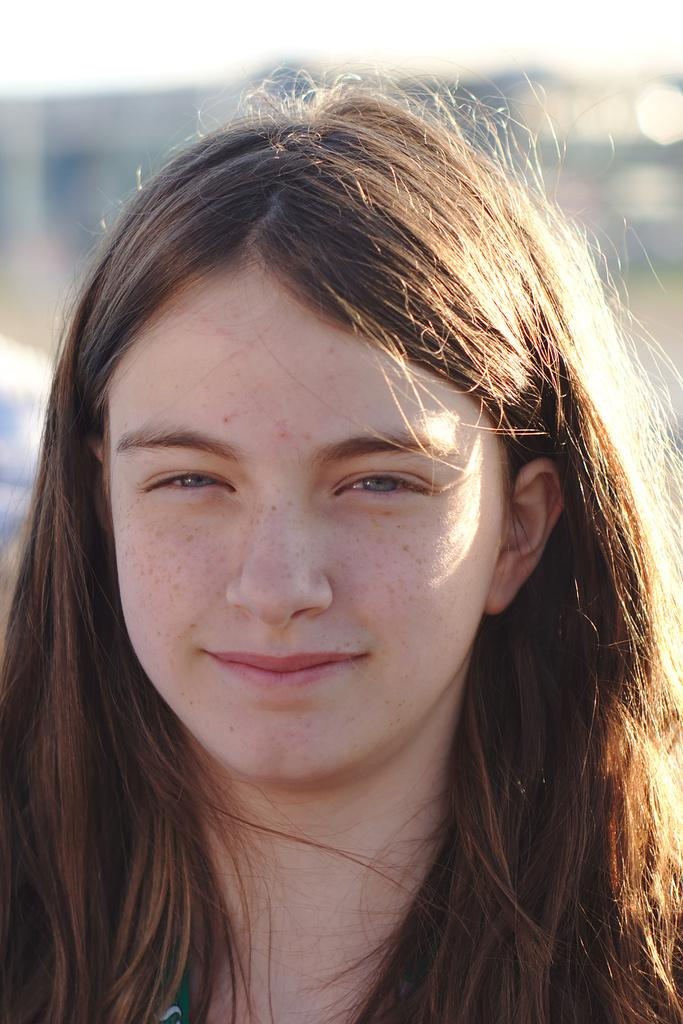Who is the main subject in the image? There is a girl in the image. What can be observed about the background of the image? The background of the image is blurred. What reason does the girl give for walking in the image? There is no indication of the girl walking in the image, nor is there any information about her reasons for doing so. 